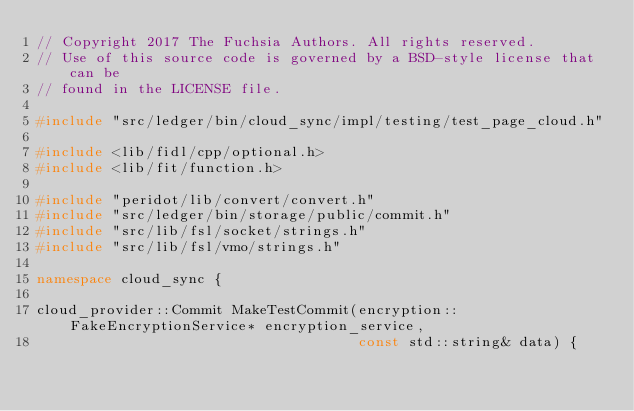<code> <loc_0><loc_0><loc_500><loc_500><_C++_>// Copyright 2017 The Fuchsia Authors. All rights reserved.
// Use of this source code is governed by a BSD-style license that can be
// found in the LICENSE file.

#include "src/ledger/bin/cloud_sync/impl/testing/test_page_cloud.h"

#include <lib/fidl/cpp/optional.h>
#include <lib/fit/function.h>

#include "peridot/lib/convert/convert.h"
#include "src/ledger/bin/storage/public/commit.h"
#include "src/lib/fsl/socket/strings.h"
#include "src/lib/fsl/vmo/strings.h"

namespace cloud_sync {

cloud_provider::Commit MakeTestCommit(encryption::FakeEncryptionService* encryption_service,
                                      const std::string& data) {</code> 